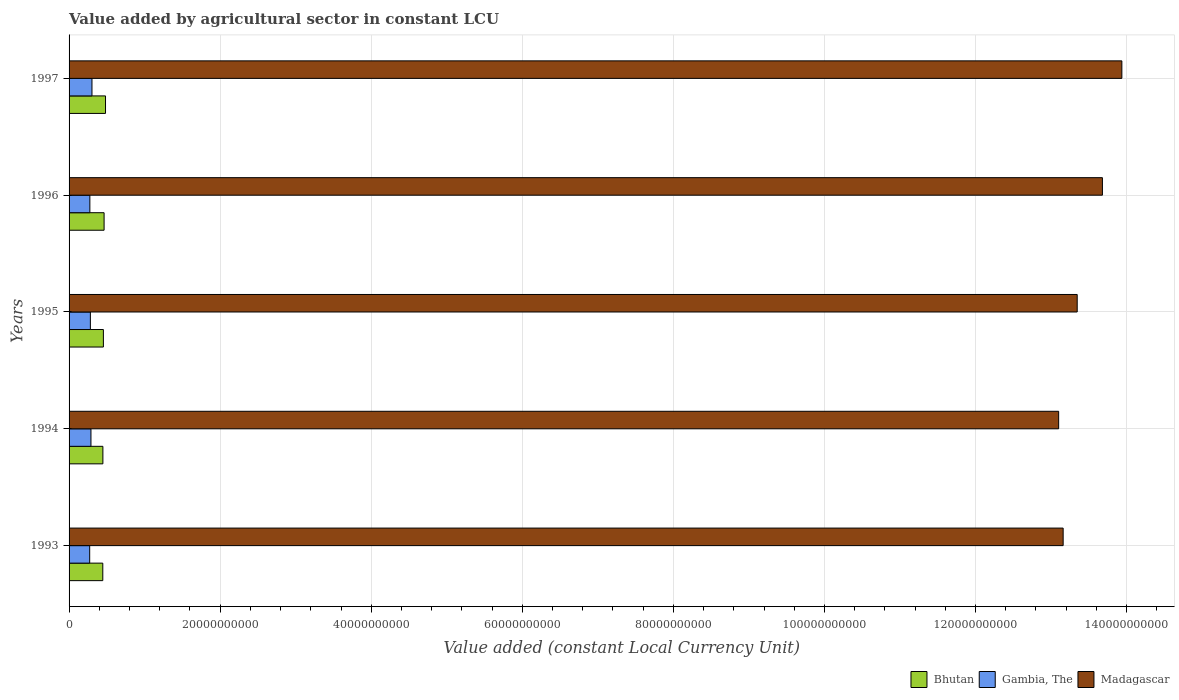Are the number of bars per tick equal to the number of legend labels?
Keep it short and to the point. Yes. How many bars are there on the 5th tick from the top?
Give a very brief answer. 3. What is the label of the 4th group of bars from the top?
Provide a short and direct response. 1994. In how many cases, is the number of bars for a given year not equal to the number of legend labels?
Your response must be concise. 0. What is the value added by agricultural sector in Bhutan in 1994?
Ensure brevity in your answer.  4.48e+09. Across all years, what is the maximum value added by agricultural sector in Gambia, The?
Offer a very short reply. 3.03e+09. Across all years, what is the minimum value added by agricultural sector in Madagascar?
Your response must be concise. 1.31e+11. In which year was the value added by agricultural sector in Gambia, The maximum?
Offer a terse response. 1997. What is the total value added by agricultural sector in Gambia, The in the graph?
Provide a succinct answer. 1.42e+1. What is the difference between the value added by agricultural sector in Bhutan in 1996 and that in 1997?
Make the answer very short. -1.86e+08. What is the difference between the value added by agricultural sector in Bhutan in 1993 and the value added by agricultural sector in Gambia, The in 1995?
Make the answer very short. 1.64e+09. What is the average value added by agricultural sector in Madagascar per year?
Provide a succinct answer. 1.34e+11. In the year 1997, what is the difference between the value added by agricultural sector in Gambia, The and value added by agricultural sector in Bhutan?
Provide a succinct answer. -1.79e+09. What is the ratio of the value added by agricultural sector in Gambia, The in 1995 to that in 1996?
Your response must be concise. 1.03. What is the difference between the highest and the second highest value added by agricultural sector in Madagascar?
Your answer should be very brief. 2.57e+09. What is the difference between the highest and the lowest value added by agricultural sector in Gambia, The?
Your response must be concise. 3.03e+08. What does the 3rd bar from the top in 1995 represents?
Your response must be concise. Bhutan. What does the 3rd bar from the bottom in 1996 represents?
Your response must be concise. Madagascar. How many bars are there?
Ensure brevity in your answer.  15. Are the values on the major ticks of X-axis written in scientific E-notation?
Give a very brief answer. No. What is the title of the graph?
Provide a succinct answer. Value added by agricultural sector in constant LCU. What is the label or title of the X-axis?
Provide a short and direct response. Value added (constant Local Currency Unit). What is the label or title of the Y-axis?
Offer a very short reply. Years. What is the Value added (constant Local Currency Unit) in Bhutan in 1993?
Ensure brevity in your answer.  4.46e+09. What is the Value added (constant Local Currency Unit) in Gambia, The in 1993?
Ensure brevity in your answer.  2.73e+09. What is the Value added (constant Local Currency Unit) in Madagascar in 1993?
Your answer should be very brief. 1.32e+11. What is the Value added (constant Local Currency Unit) in Bhutan in 1994?
Provide a succinct answer. 4.48e+09. What is the Value added (constant Local Currency Unit) of Gambia, The in 1994?
Provide a short and direct response. 2.90e+09. What is the Value added (constant Local Currency Unit) in Madagascar in 1994?
Your answer should be compact. 1.31e+11. What is the Value added (constant Local Currency Unit) of Bhutan in 1995?
Keep it short and to the point. 4.54e+09. What is the Value added (constant Local Currency Unit) of Gambia, The in 1995?
Give a very brief answer. 2.82e+09. What is the Value added (constant Local Currency Unit) of Madagascar in 1995?
Provide a short and direct response. 1.33e+11. What is the Value added (constant Local Currency Unit) in Bhutan in 1996?
Your answer should be compact. 4.64e+09. What is the Value added (constant Local Currency Unit) of Gambia, The in 1996?
Ensure brevity in your answer.  2.75e+09. What is the Value added (constant Local Currency Unit) of Madagascar in 1996?
Your response must be concise. 1.37e+11. What is the Value added (constant Local Currency Unit) in Bhutan in 1997?
Offer a very short reply. 4.82e+09. What is the Value added (constant Local Currency Unit) in Gambia, The in 1997?
Your response must be concise. 3.03e+09. What is the Value added (constant Local Currency Unit) of Madagascar in 1997?
Your answer should be very brief. 1.39e+11. Across all years, what is the maximum Value added (constant Local Currency Unit) of Bhutan?
Keep it short and to the point. 4.82e+09. Across all years, what is the maximum Value added (constant Local Currency Unit) of Gambia, The?
Your response must be concise. 3.03e+09. Across all years, what is the maximum Value added (constant Local Currency Unit) in Madagascar?
Ensure brevity in your answer.  1.39e+11. Across all years, what is the minimum Value added (constant Local Currency Unit) of Bhutan?
Offer a very short reply. 4.46e+09. Across all years, what is the minimum Value added (constant Local Currency Unit) of Gambia, The?
Offer a very short reply. 2.73e+09. Across all years, what is the minimum Value added (constant Local Currency Unit) in Madagascar?
Your answer should be very brief. 1.31e+11. What is the total Value added (constant Local Currency Unit) in Bhutan in the graph?
Your answer should be very brief. 2.29e+1. What is the total Value added (constant Local Currency Unit) of Gambia, The in the graph?
Offer a very short reply. 1.42e+1. What is the total Value added (constant Local Currency Unit) of Madagascar in the graph?
Keep it short and to the point. 6.72e+11. What is the difference between the Value added (constant Local Currency Unit) of Bhutan in 1993 and that in 1994?
Provide a short and direct response. -1.26e+07. What is the difference between the Value added (constant Local Currency Unit) of Gambia, The in 1993 and that in 1994?
Make the answer very short. -1.68e+08. What is the difference between the Value added (constant Local Currency Unit) of Madagascar in 1993 and that in 1994?
Provide a succinct answer. 5.95e+08. What is the difference between the Value added (constant Local Currency Unit) in Bhutan in 1993 and that in 1995?
Keep it short and to the point. -8.03e+07. What is the difference between the Value added (constant Local Currency Unit) in Gambia, The in 1993 and that in 1995?
Keep it short and to the point. -9.19e+07. What is the difference between the Value added (constant Local Currency Unit) in Madagascar in 1993 and that in 1995?
Your answer should be very brief. -1.86e+09. What is the difference between the Value added (constant Local Currency Unit) in Bhutan in 1993 and that in 1996?
Offer a very short reply. -1.73e+08. What is the difference between the Value added (constant Local Currency Unit) of Gambia, The in 1993 and that in 1996?
Keep it short and to the point. -2.24e+07. What is the difference between the Value added (constant Local Currency Unit) of Madagascar in 1993 and that in 1996?
Your answer should be compact. -5.20e+09. What is the difference between the Value added (constant Local Currency Unit) of Bhutan in 1993 and that in 1997?
Offer a terse response. -3.60e+08. What is the difference between the Value added (constant Local Currency Unit) in Gambia, The in 1993 and that in 1997?
Keep it short and to the point. -3.03e+08. What is the difference between the Value added (constant Local Currency Unit) of Madagascar in 1993 and that in 1997?
Provide a short and direct response. -7.77e+09. What is the difference between the Value added (constant Local Currency Unit) in Bhutan in 1994 and that in 1995?
Offer a very short reply. -6.77e+07. What is the difference between the Value added (constant Local Currency Unit) in Gambia, The in 1994 and that in 1995?
Ensure brevity in your answer.  7.64e+07. What is the difference between the Value added (constant Local Currency Unit) in Madagascar in 1994 and that in 1995?
Your response must be concise. -2.46e+09. What is the difference between the Value added (constant Local Currency Unit) in Bhutan in 1994 and that in 1996?
Ensure brevity in your answer.  -1.61e+08. What is the difference between the Value added (constant Local Currency Unit) in Gambia, The in 1994 and that in 1996?
Offer a terse response. 1.46e+08. What is the difference between the Value added (constant Local Currency Unit) of Madagascar in 1994 and that in 1996?
Provide a succinct answer. -5.79e+09. What is the difference between the Value added (constant Local Currency Unit) of Bhutan in 1994 and that in 1997?
Your answer should be very brief. -3.47e+08. What is the difference between the Value added (constant Local Currency Unit) in Gambia, The in 1994 and that in 1997?
Provide a succinct answer. -1.35e+08. What is the difference between the Value added (constant Local Currency Unit) in Madagascar in 1994 and that in 1997?
Your answer should be very brief. -8.37e+09. What is the difference between the Value added (constant Local Currency Unit) in Bhutan in 1995 and that in 1996?
Ensure brevity in your answer.  -9.31e+07. What is the difference between the Value added (constant Local Currency Unit) of Gambia, The in 1995 and that in 1996?
Provide a succinct answer. 6.95e+07. What is the difference between the Value added (constant Local Currency Unit) of Madagascar in 1995 and that in 1996?
Your response must be concise. -3.34e+09. What is the difference between the Value added (constant Local Currency Unit) in Bhutan in 1995 and that in 1997?
Your answer should be compact. -2.79e+08. What is the difference between the Value added (constant Local Currency Unit) of Gambia, The in 1995 and that in 1997?
Offer a terse response. -2.11e+08. What is the difference between the Value added (constant Local Currency Unit) in Madagascar in 1995 and that in 1997?
Keep it short and to the point. -5.91e+09. What is the difference between the Value added (constant Local Currency Unit) of Bhutan in 1996 and that in 1997?
Your response must be concise. -1.86e+08. What is the difference between the Value added (constant Local Currency Unit) of Gambia, The in 1996 and that in 1997?
Your answer should be very brief. -2.81e+08. What is the difference between the Value added (constant Local Currency Unit) of Madagascar in 1996 and that in 1997?
Offer a terse response. -2.57e+09. What is the difference between the Value added (constant Local Currency Unit) in Bhutan in 1993 and the Value added (constant Local Currency Unit) in Gambia, The in 1994?
Ensure brevity in your answer.  1.57e+09. What is the difference between the Value added (constant Local Currency Unit) of Bhutan in 1993 and the Value added (constant Local Currency Unit) of Madagascar in 1994?
Provide a succinct answer. -1.27e+11. What is the difference between the Value added (constant Local Currency Unit) in Gambia, The in 1993 and the Value added (constant Local Currency Unit) in Madagascar in 1994?
Offer a very short reply. -1.28e+11. What is the difference between the Value added (constant Local Currency Unit) in Bhutan in 1993 and the Value added (constant Local Currency Unit) in Gambia, The in 1995?
Your answer should be very brief. 1.64e+09. What is the difference between the Value added (constant Local Currency Unit) in Bhutan in 1993 and the Value added (constant Local Currency Unit) in Madagascar in 1995?
Give a very brief answer. -1.29e+11. What is the difference between the Value added (constant Local Currency Unit) in Gambia, The in 1993 and the Value added (constant Local Currency Unit) in Madagascar in 1995?
Offer a very short reply. -1.31e+11. What is the difference between the Value added (constant Local Currency Unit) in Bhutan in 1993 and the Value added (constant Local Currency Unit) in Gambia, The in 1996?
Your response must be concise. 1.71e+09. What is the difference between the Value added (constant Local Currency Unit) of Bhutan in 1993 and the Value added (constant Local Currency Unit) of Madagascar in 1996?
Offer a terse response. -1.32e+11. What is the difference between the Value added (constant Local Currency Unit) in Gambia, The in 1993 and the Value added (constant Local Currency Unit) in Madagascar in 1996?
Make the answer very short. -1.34e+11. What is the difference between the Value added (constant Local Currency Unit) in Bhutan in 1993 and the Value added (constant Local Currency Unit) in Gambia, The in 1997?
Offer a very short reply. 1.43e+09. What is the difference between the Value added (constant Local Currency Unit) in Bhutan in 1993 and the Value added (constant Local Currency Unit) in Madagascar in 1997?
Make the answer very short. -1.35e+11. What is the difference between the Value added (constant Local Currency Unit) of Gambia, The in 1993 and the Value added (constant Local Currency Unit) of Madagascar in 1997?
Your answer should be compact. -1.37e+11. What is the difference between the Value added (constant Local Currency Unit) in Bhutan in 1994 and the Value added (constant Local Currency Unit) in Gambia, The in 1995?
Offer a terse response. 1.66e+09. What is the difference between the Value added (constant Local Currency Unit) in Bhutan in 1994 and the Value added (constant Local Currency Unit) in Madagascar in 1995?
Your answer should be compact. -1.29e+11. What is the difference between the Value added (constant Local Currency Unit) in Gambia, The in 1994 and the Value added (constant Local Currency Unit) in Madagascar in 1995?
Keep it short and to the point. -1.31e+11. What is the difference between the Value added (constant Local Currency Unit) in Bhutan in 1994 and the Value added (constant Local Currency Unit) in Gambia, The in 1996?
Your answer should be very brief. 1.73e+09. What is the difference between the Value added (constant Local Currency Unit) of Bhutan in 1994 and the Value added (constant Local Currency Unit) of Madagascar in 1996?
Provide a short and direct response. -1.32e+11. What is the difference between the Value added (constant Local Currency Unit) in Gambia, The in 1994 and the Value added (constant Local Currency Unit) in Madagascar in 1996?
Your answer should be compact. -1.34e+11. What is the difference between the Value added (constant Local Currency Unit) in Bhutan in 1994 and the Value added (constant Local Currency Unit) in Gambia, The in 1997?
Offer a very short reply. 1.44e+09. What is the difference between the Value added (constant Local Currency Unit) of Bhutan in 1994 and the Value added (constant Local Currency Unit) of Madagascar in 1997?
Offer a very short reply. -1.35e+11. What is the difference between the Value added (constant Local Currency Unit) in Gambia, The in 1994 and the Value added (constant Local Currency Unit) in Madagascar in 1997?
Provide a succinct answer. -1.36e+11. What is the difference between the Value added (constant Local Currency Unit) of Bhutan in 1995 and the Value added (constant Local Currency Unit) of Gambia, The in 1996?
Give a very brief answer. 1.79e+09. What is the difference between the Value added (constant Local Currency Unit) in Bhutan in 1995 and the Value added (constant Local Currency Unit) in Madagascar in 1996?
Your response must be concise. -1.32e+11. What is the difference between the Value added (constant Local Currency Unit) in Gambia, The in 1995 and the Value added (constant Local Currency Unit) in Madagascar in 1996?
Make the answer very short. -1.34e+11. What is the difference between the Value added (constant Local Currency Unit) in Bhutan in 1995 and the Value added (constant Local Currency Unit) in Gambia, The in 1997?
Offer a terse response. 1.51e+09. What is the difference between the Value added (constant Local Currency Unit) of Bhutan in 1995 and the Value added (constant Local Currency Unit) of Madagascar in 1997?
Your answer should be compact. -1.35e+11. What is the difference between the Value added (constant Local Currency Unit) in Gambia, The in 1995 and the Value added (constant Local Currency Unit) in Madagascar in 1997?
Provide a short and direct response. -1.37e+11. What is the difference between the Value added (constant Local Currency Unit) of Bhutan in 1996 and the Value added (constant Local Currency Unit) of Gambia, The in 1997?
Offer a very short reply. 1.61e+09. What is the difference between the Value added (constant Local Currency Unit) in Bhutan in 1996 and the Value added (constant Local Currency Unit) in Madagascar in 1997?
Give a very brief answer. -1.35e+11. What is the difference between the Value added (constant Local Currency Unit) of Gambia, The in 1996 and the Value added (constant Local Currency Unit) of Madagascar in 1997?
Offer a very short reply. -1.37e+11. What is the average Value added (constant Local Currency Unit) of Bhutan per year?
Give a very brief answer. 4.59e+09. What is the average Value added (constant Local Currency Unit) in Gambia, The per year?
Your answer should be compact. 2.85e+09. What is the average Value added (constant Local Currency Unit) in Madagascar per year?
Ensure brevity in your answer.  1.34e+11. In the year 1993, what is the difference between the Value added (constant Local Currency Unit) in Bhutan and Value added (constant Local Currency Unit) in Gambia, The?
Your answer should be very brief. 1.74e+09. In the year 1993, what is the difference between the Value added (constant Local Currency Unit) in Bhutan and Value added (constant Local Currency Unit) in Madagascar?
Your response must be concise. -1.27e+11. In the year 1993, what is the difference between the Value added (constant Local Currency Unit) in Gambia, The and Value added (constant Local Currency Unit) in Madagascar?
Your answer should be very brief. -1.29e+11. In the year 1994, what is the difference between the Value added (constant Local Currency Unit) of Bhutan and Value added (constant Local Currency Unit) of Gambia, The?
Make the answer very short. 1.58e+09. In the year 1994, what is the difference between the Value added (constant Local Currency Unit) of Bhutan and Value added (constant Local Currency Unit) of Madagascar?
Your answer should be compact. -1.27e+11. In the year 1994, what is the difference between the Value added (constant Local Currency Unit) in Gambia, The and Value added (constant Local Currency Unit) in Madagascar?
Your answer should be compact. -1.28e+11. In the year 1995, what is the difference between the Value added (constant Local Currency Unit) of Bhutan and Value added (constant Local Currency Unit) of Gambia, The?
Give a very brief answer. 1.72e+09. In the year 1995, what is the difference between the Value added (constant Local Currency Unit) of Bhutan and Value added (constant Local Currency Unit) of Madagascar?
Offer a very short reply. -1.29e+11. In the year 1995, what is the difference between the Value added (constant Local Currency Unit) in Gambia, The and Value added (constant Local Currency Unit) in Madagascar?
Offer a terse response. -1.31e+11. In the year 1996, what is the difference between the Value added (constant Local Currency Unit) in Bhutan and Value added (constant Local Currency Unit) in Gambia, The?
Your answer should be very brief. 1.89e+09. In the year 1996, what is the difference between the Value added (constant Local Currency Unit) in Bhutan and Value added (constant Local Currency Unit) in Madagascar?
Your response must be concise. -1.32e+11. In the year 1996, what is the difference between the Value added (constant Local Currency Unit) of Gambia, The and Value added (constant Local Currency Unit) of Madagascar?
Ensure brevity in your answer.  -1.34e+11. In the year 1997, what is the difference between the Value added (constant Local Currency Unit) of Bhutan and Value added (constant Local Currency Unit) of Gambia, The?
Provide a succinct answer. 1.79e+09. In the year 1997, what is the difference between the Value added (constant Local Currency Unit) in Bhutan and Value added (constant Local Currency Unit) in Madagascar?
Your answer should be very brief. -1.35e+11. In the year 1997, what is the difference between the Value added (constant Local Currency Unit) in Gambia, The and Value added (constant Local Currency Unit) in Madagascar?
Provide a short and direct response. -1.36e+11. What is the ratio of the Value added (constant Local Currency Unit) of Bhutan in 1993 to that in 1994?
Offer a terse response. 1. What is the ratio of the Value added (constant Local Currency Unit) of Gambia, The in 1993 to that in 1994?
Offer a terse response. 0.94. What is the ratio of the Value added (constant Local Currency Unit) in Madagascar in 1993 to that in 1994?
Your response must be concise. 1. What is the ratio of the Value added (constant Local Currency Unit) in Bhutan in 1993 to that in 1995?
Offer a terse response. 0.98. What is the ratio of the Value added (constant Local Currency Unit) in Gambia, The in 1993 to that in 1995?
Offer a terse response. 0.97. What is the ratio of the Value added (constant Local Currency Unit) in Madagascar in 1993 to that in 1995?
Your response must be concise. 0.99. What is the ratio of the Value added (constant Local Currency Unit) in Bhutan in 1993 to that in 1996?
Make the answer very short. 0.96. What is the ratio of the Value added (constant Local Currency Unit) in Gambia, The in 1993 to that in 1996?
Ensure brevity in your answer.  0.99. What is the ratio of the Value added (constant Local Currency Unit) in Bhutan in 1993 to that in 1997?
Give a very brief answer. 0.93. What is the ratio of the Value added (constant Local Currency Unit) of Madagascar in 1993 to that in 1997?
Keep it short and to the point. 0.94. What is the ratio of the Value added (constant Local Currency Unit) of Bhutan in 1994 to that in 1995?
Your answer should be very brief. 0.99. What is the ratio of the Value added (constant Local Currency Unit) in Gambia, The in 1994 to that in 1995?
Offer a very short reply. 1.03. What is the ratio of the Value added (constant Local Currency Unit) of Madagascar in 1994 to that in 1995?
Ensure brevity in your answer.  0.98. What is the ratio of the Value added (constant Local Currency Unit) of Bhutan in 1994 to that in 1996?
Provide a short and direct response. 0.97. What is the ratio of the Value added (constant Local Currency Unit) of Gambia, The in 1994 to that in 1996?
Keep it short and to the point. 1.05. What is the ratio of the Value added (constant Local Currency Unit) of Madagascar in 1994 to that in 1996?
Make the answer very short. 0.96. What is the ratio of the Value added (constant Local Currency Unit) of Bhutan in 1994 to that in 1997?
Offer a terse response. 0.93. What is the ratio of the Value added (constant Local Currency Unit) in Gambia, The in 1994 to that in 1997?
Your answer should be compact. 0.96. What is the ratio of the Value added (constant Local Currency Unit) of Bhutan in 1995 to that in 1996?
Offer a very short reply. 0.98. What is the ratio of the Value added (constant Local Currency Unit) of Gambia, The in 1995 to that in 1996?
Keep it short and to the point. 1.03. What is the ratio of the Value added (constant Local Currency Unit) in Madagascar in 1995 to that in 1996?
Offer a very short reply. 0.98. What is the ratio of the Value added (constant Local Currency Unit) in Bhutan in 1995 to that in 1997?
Keep it short and to the point. 0.94. What is the ratio of the Value added (constant Local Currency Unit) in Gambia, The in 1995 to that in 1997?
Your response must be concise. 0.93. What is the ratio of the Value added (constant Local Currency Unit) of Madagascar in 1995 to that in 1997?
Your response must be concise. 0.96. What is the ratio of the Value added (constant Local Currency Unit) in Bhutan in 1996 to that in 1997?
Make the answer very short. 0.96. What is the ratio of the Value added (constant Local Currency Unit) in Gambia, The in 1996 to that in 1997?
Your answer should be compact. 0.91. What is the ratio of the Value added (constant Local Currency Unit) in Madagascar in 1996 to that in 1997?
Your answer should be very brief. 0.98. What is the difference between the highest and the second highest Value added (constant Local Currency Unit) in Bhutan?
Offer a terse response. 1.86e+08. What is the difference between the highest and the second highest Value added (constant Local Currency Unit) in Gambia, The?
Provide a succinct answer. 1.35e+08. What is the difference between the highest and the second highest Value added (constant Local Currency Unit) in Madagascar?
Ensure brevity in your answer.  2.57e+09. What is the difference between the highest and the lowest Value added (constant Local Currency Unit) of Bhutan?
Give a very brief answer. 3.60e+08. What is the difference between the highest and the lowest Value added (constant Local Currency Unit) of Gambia, The?
Your response must be concise. 3.03e+08. What is the difference between the highest and the lowest Value added (constant Local Currency Unit) of Madagascar?
Make the answer very short. 8.37e+09. 